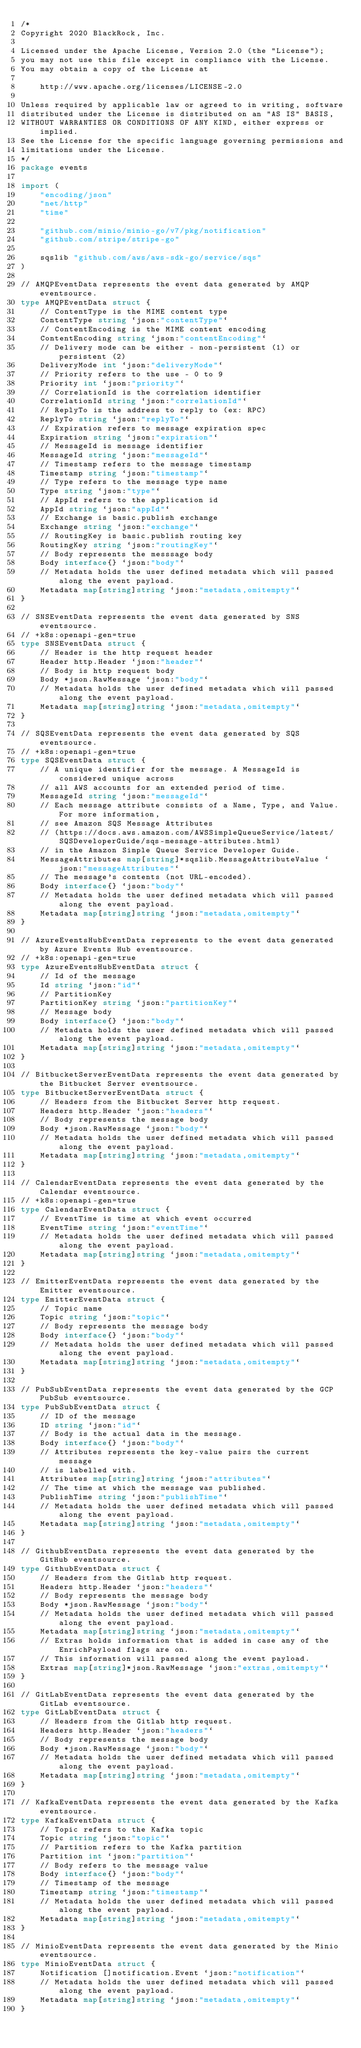Convert code to text. <code><loc_0><loc_0><loc_500><loc_500><_Go_>/*
Copyright 2020 BlackRock, Inc.

Licensed under the Apache License, Version 2.0 (the "License");
you may not use this file except in compliance with the License.
You may obtain a copy of the License at

	http://www.apache.org/licenses/LICENSE-2.0

Unless required by applicable law or agreed to in writing, software
distributed under the License is distributed on an "AS IS" BASIS,
WITHOUT WARRANTIES OR CONDITIONS OF ANY KIND, either express or implied.
See the License for the specific language governing permissions and
limitations under the License.
*/
package events

import (
	"encoding/json"
	"net/http"
	"time"

	"github.com/minio/minio-go/v7/pkg/notification"
	"github.com/stripe/stripe-go"

	sqslib "github.com/aws/aws-sdk-go/service/sqs"
)

// AMQPEventData represents the event data generated by AMQP eventsource.
type AMQPEventData struct {
	// ContentType is the MIME content type
	ContentType string `json:"contentType"`
	// ContentEncoding is the MIME content encoding
	ContentEncoding string `json:"contentEncoding"`
	// Delivery mode can be either - non-persistent (1) or persistent (2)
	DeliveryMode int `json:"deliveryMode"`
	// Priority refers to the use - 0 to 9
	Priority int `json:"priority"`
	// CorrelationId is the correlation identifier
	CorrelationId string `json:"correlationId"`
	// ReplyTo is the address to reply to (ex: RPC)
	ReplyTo string `json:"replyTo"`
	// Expiration refers to message expiration spec
	Expiration string `json:"expiration"`
	// MessageId is message identifier
	MessageId string `json:"messageId"`
	// Timestamp refers to the message timestamp
	Timestamp string `json:"timestamp"`
	// Type refers to the message type name
	Type string `json:"type"`
	// AppId refers to the application id
	AppId string `json:"appId"`
	// Exchange is basic.publish exchange
	Exchange string `json:"exchange"`
	// RoutingKey is basic.publish routing key
	RoutingKey string `json:"routingKey"`
	// Body represents the messsage body
	Body interface{} `json:"body"`
	// Metadata holds the user defined metadata which will passed along the event payload.
	Metadata map[string]string `json:"metadata,omitempty"`
}

// SNSEventData represents the event data generated by SNS eventsource.
// +k8s:openapi-gen=true
type SNSEventData struct {
	// Header is the http request header
	Header http.Header `json:"header"`
	// Body is http request body
	Body *json.RawMessage `json:"body"`
	// Metadata holds the user defined metadata which will passed along the event payload.
	Metadata map[string]string `json:"metadata,omitempty"`
}

// SQSEventData represents the event data generated by SQS eventsource.
// +k8s:openapi-gen=true
type SQSEventData struct {
	// A unique identifier for the message. A MessageId is considered unique across
	// all AWS accounts for an extended period of time.
	MessageId string `json:"messageId"`
	// Each message attribute consists of a Name, Type, and Value. For more information,
	// see Amazon SQS Message Attributes
	// (https://docs.aws.amazon.com/AWSSimpleQueueService/latest/SQSDeveloperGuide/sqs-message-attributes.html)
	// in the Amazon Simple Queue Service Developer Guide.
	MessageAttributes map[string]*sqslib.MessageAttributeValue `json:"messageAttributes"`
	// The message's contents (not URL-encoded).
	Body interface{} `json:"body"`
	// Metadata holds the user defined metadata which will passed along the event payload.
	Metadata map[string]string `json:"metadata,omitempty"`
}

// AzureEventsHubEventData represents to the event data generated by Azure Events Hub eventsource.
// +k8s:openapi-gen=true
type AzureEventsHubEventData struct {
	// Id of the message
	Id string `json:"id"`
	// PartitionKey
	PartitionKey string `json:"partitionKey"`
	// Message body
	Body interface{} `json:"body"`
	// Metadata holds the user defined metadata which will passed along the event payload.
	Metadata map[string]string `json:"metadata,omitempty"`
}

// BitbucketServerEventData represents the event data generated by the Bitbucket Server eventsource.
type BitbucketServerEventData struct {
	// Headers from the Bitbucket Server http request.
	Headers http.Header `json:"headers"`
	// Body represents the message body
	Body *json.RawMessage `json:"body"`
	// Metadata holds the user defined metadata which will passed along the event payload.
	Metadata map[string]string `json:"metadata,omitempty"`
}

// CalendarEventData represents the event data generated by the Calendar eventsource.
// +k8s:openapi-gen=true
type CalendarEventData struct {
	// EventTime is time at which event occurred
	EventTime string `json:"eventTime"`
	// Metadata holds the user defined metadata which will passed along the event payload.
	Metadata map[string]string `json:"metadata,omitempty"`
}

// EmitterEventData represents the event data generated by the Emitter eventsource.
type EmitterEventData struct {
	// Topic name
	Topic string `json:"topic"`
	// Body represents the message body
	Body interface{} `json:"body"`
	// Metadata holds the user defined metadata which will passed along the event payload.
	Metadata map[string]string `json:"metadata,omitempty"`
}

// PubSubEventData represents the event data generated by the GCP PubSub eventsource.
type PubSubEventData struct {
	// ID of the message
	ID string `json:"id"`
	// Body is the actual data in the message.
	Body interface{} `json:"body"`
	// Attributes represents the key-value pairs the current message
	// is labelled with.
	Attributes map[string]string `json:"attributes"`
	// The time at which the message was published.
	PublishTime string `json:"publishTime"`
	// Metadata holds the user defined metadata which will passed along the event payload.
	Metadata map[string]string `json:"metadata,omitempty"`
}

// GithubEventData represents the event data generated by the GitHub eventsource.
type GithubEventData struct {
	// Headers from the Gitlab http request.
	Headers http.Header `json:"headers"`
	// Body represents the message body
	Body *json.RawMessage `json:"body"`
	// Metadata holds the user defined metadata which will passed along the event payload.
	Metadata map[string]string `json:"metadata,omitempty"`
	// Extras holds information that is added in case any of the EnrichPayload flags are on.
	// This information will passed along the event payload.
	Extras map[string]*json.RawMessage `json:"extras,omitempty"`
}

// GitLabEventData represents the event data generated by the GitLab eventsource.
type GitLabEventData struct {
	// Headers from the Gitlab http request.
	Headers http.Header `json:"headers"`
	// Body represents the message body
	Body *json.RawMessage `json:"body"`
	// Metadata holds the user defined metadata which will passed along the event payload.
	Metadata map[string]string `json:"metadata,omitempty"`
}

// KafkaEventData represents the event data generated by the Kafka eventsource.
type KafkaEventData struct {
	// Topic refers to the Kafka topic
	Topic string `json:"topic"`
	// Partition refers to the Kafka partition
	Partition int `json:"partition"`
	// Body refers to the message value
	Body interface{} `json:"body"`
	// Timestamp of the message
	Timestamp string `json:"timestamp"`
	// Metadata holds the user defined metadata which will passed along the event payload.
	Metadata map[string]string `json:"metadata,omitempty"`
}

// MinioEventData represents the event data generated by the Minio eventsource.
type MinioEventData struct {
	Notification []notification.Event `json:"notification"`
	// Metadata holds the user defined metadata which will passed along the event payload.
	Metadata map[string]string `json:"metadata,omitempty"`
}
</code> 